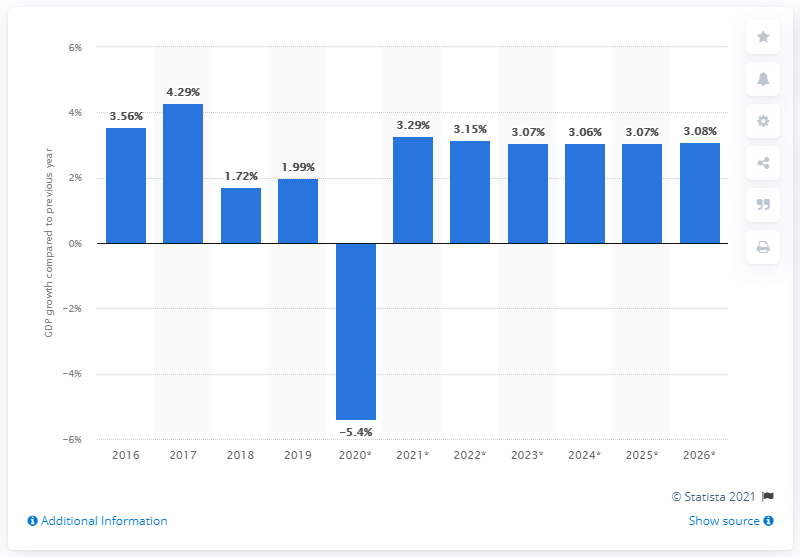Specify some key components in this picture. In 2019, Bahrain's gross domestic product (GDP) grew by 1.99%. This indicates an increase in the value of goods and services produced within the country, contributing to the overall economic growth of the nation. 